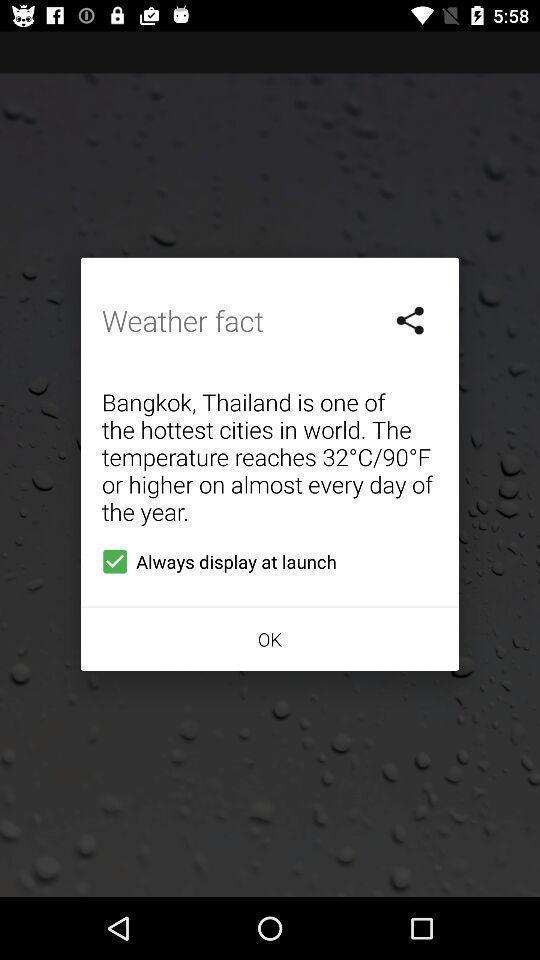Summarize the main components in this picture. Popup showing about the weather fact. 